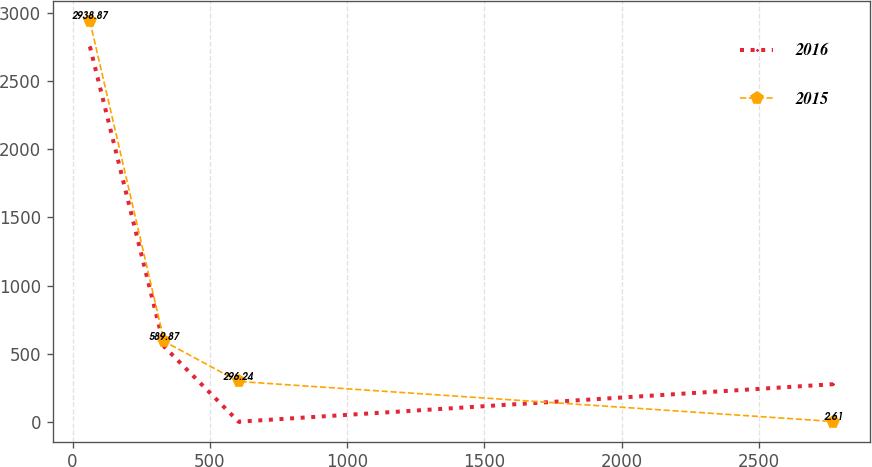<chart> <loc_0><loc_0><loc_500><loc_500><line_chart><ecel><fcel>2016<fcel>2015<nl><fcel>63.29<fcel>2753.32<fcel>2938.87<nl><fcel>333.95<fcel>551.57<fcel>589.87<nl><fcel>604.61<fcel>1.13<fcel>296.24<nl><fcel>2769.86<fcel>276.35<fcel>2.61<nl></chart> 